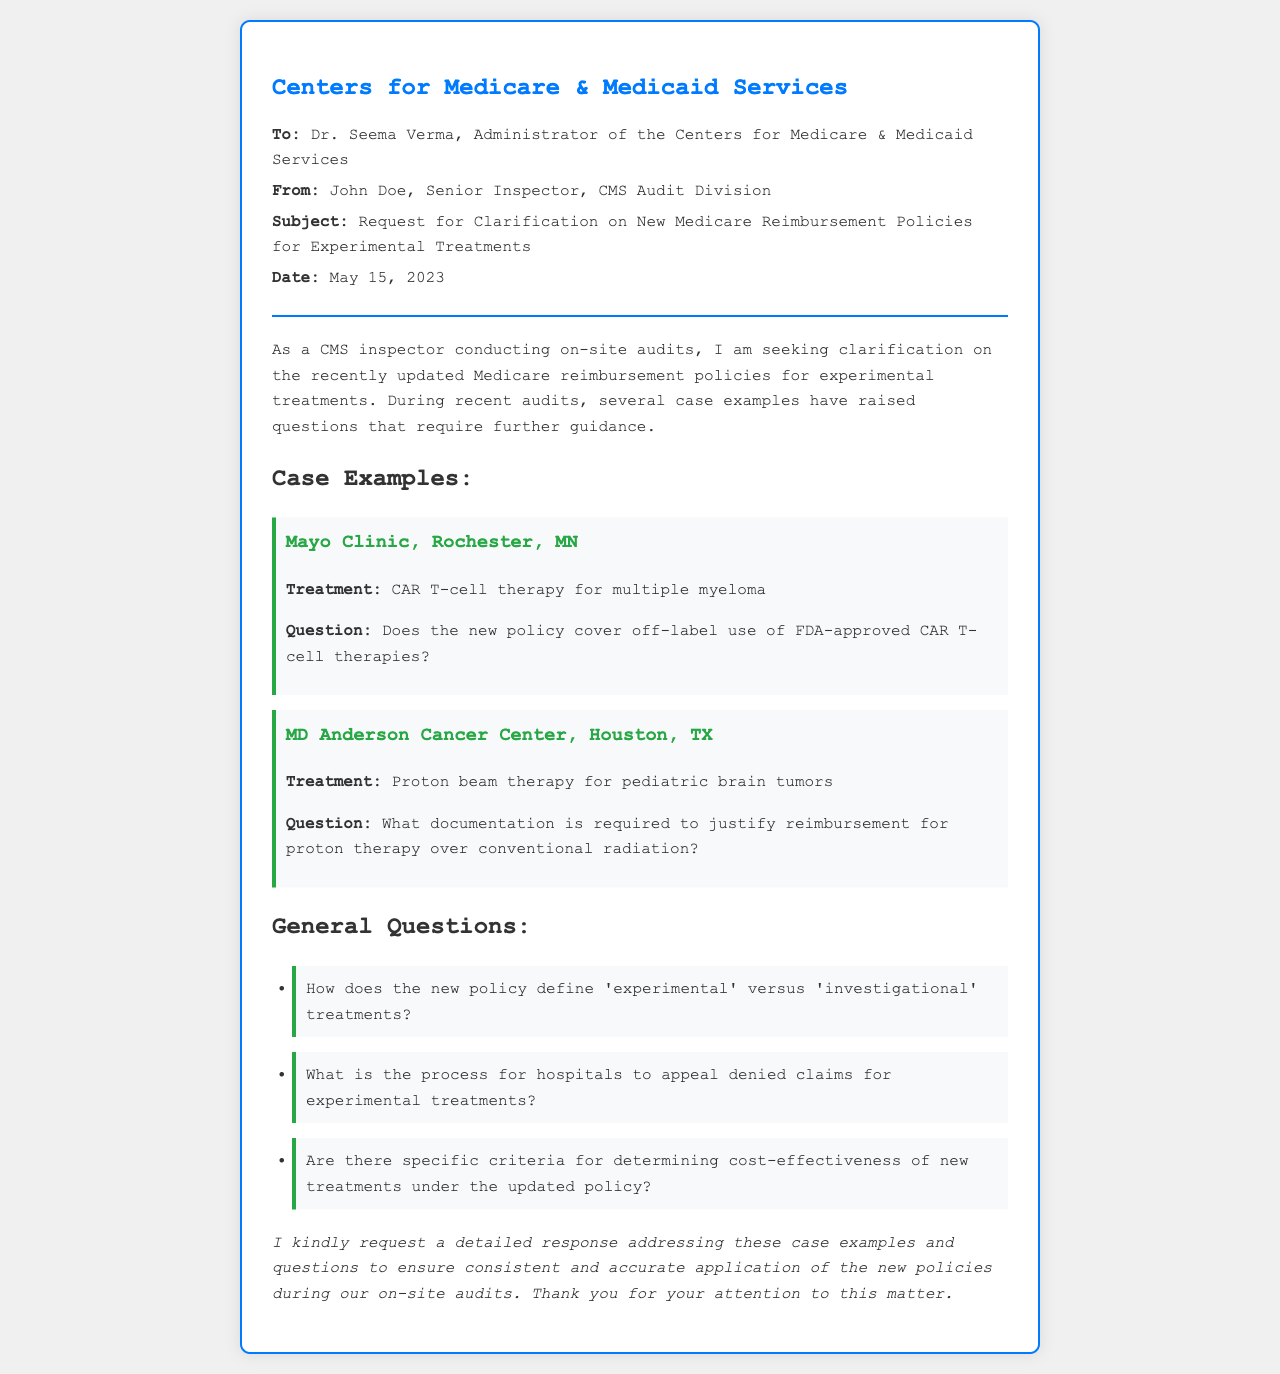What is the subject of the fax? The subject provides the main topic addressed in the fax, which is related to policies for experimental treatments.
Answer: Request for Clarification on New Medicare Reimbursement Policies for Experimental Treatments Who is the sender of the fax? The sender is identified at the top of the fax, providing their name and title.
Answer: John Doe, Senior Inspector, CMS Audit Division What is the date of the fax? The date indicates when the fax was sent, which is crucial for tracking and reference purposes.
Answer: May 15, 2023 What treatment is mentioned for Mayo Clinic? The document specifies a particular treatment associated with a specific healthcare provider, relevant for audit considerations.
Answer: CAR T-cell therapy for multiple myeloma What is the main question regarding the treatment at MD Anderson Cancer Center? This question relates to documentation requirements for a particular treatment type, which is important for the audit process.
Answer: What documentation is required to justify reimbursement for proton therapy over conventional radiation? How does the new policy define treatments? Understanding the definitions used in the policy is essential for compliance and auditing purposes.
Answer: 'Experimental' versus 'investigational' treatments What is the appeal process referenced in the document? The questioning of the appeals process is vital for handling denied claims in a healthcare setting.
Answer: Process for hospitals to appeal denied claims for experimental treatments Are there specific criteria mentioned in the new policy? This question seeks to clarify evaluation standards for new treatments as outlined in the document.
Answer: Specific criteria for determining cost-effectiveness of new treatments under the updated policy 